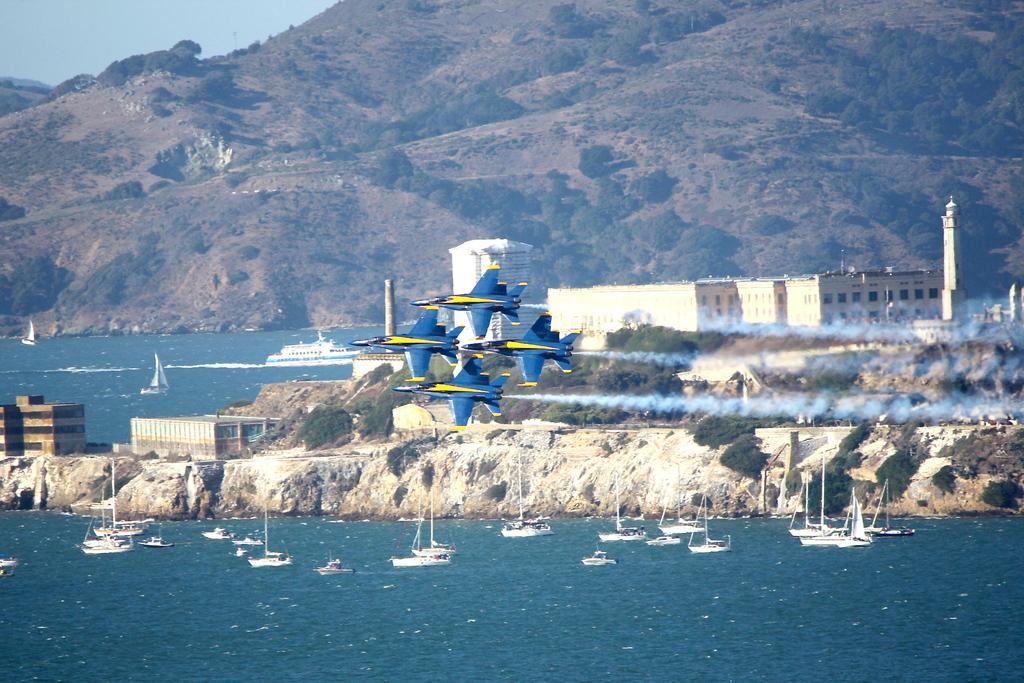How would you summarize this image in a sentence or two? In this picture we seeing 4 fighter plane which are moving simultaneously and at the background we are seeing beautiful mountain and there are many ship also near the sea. 